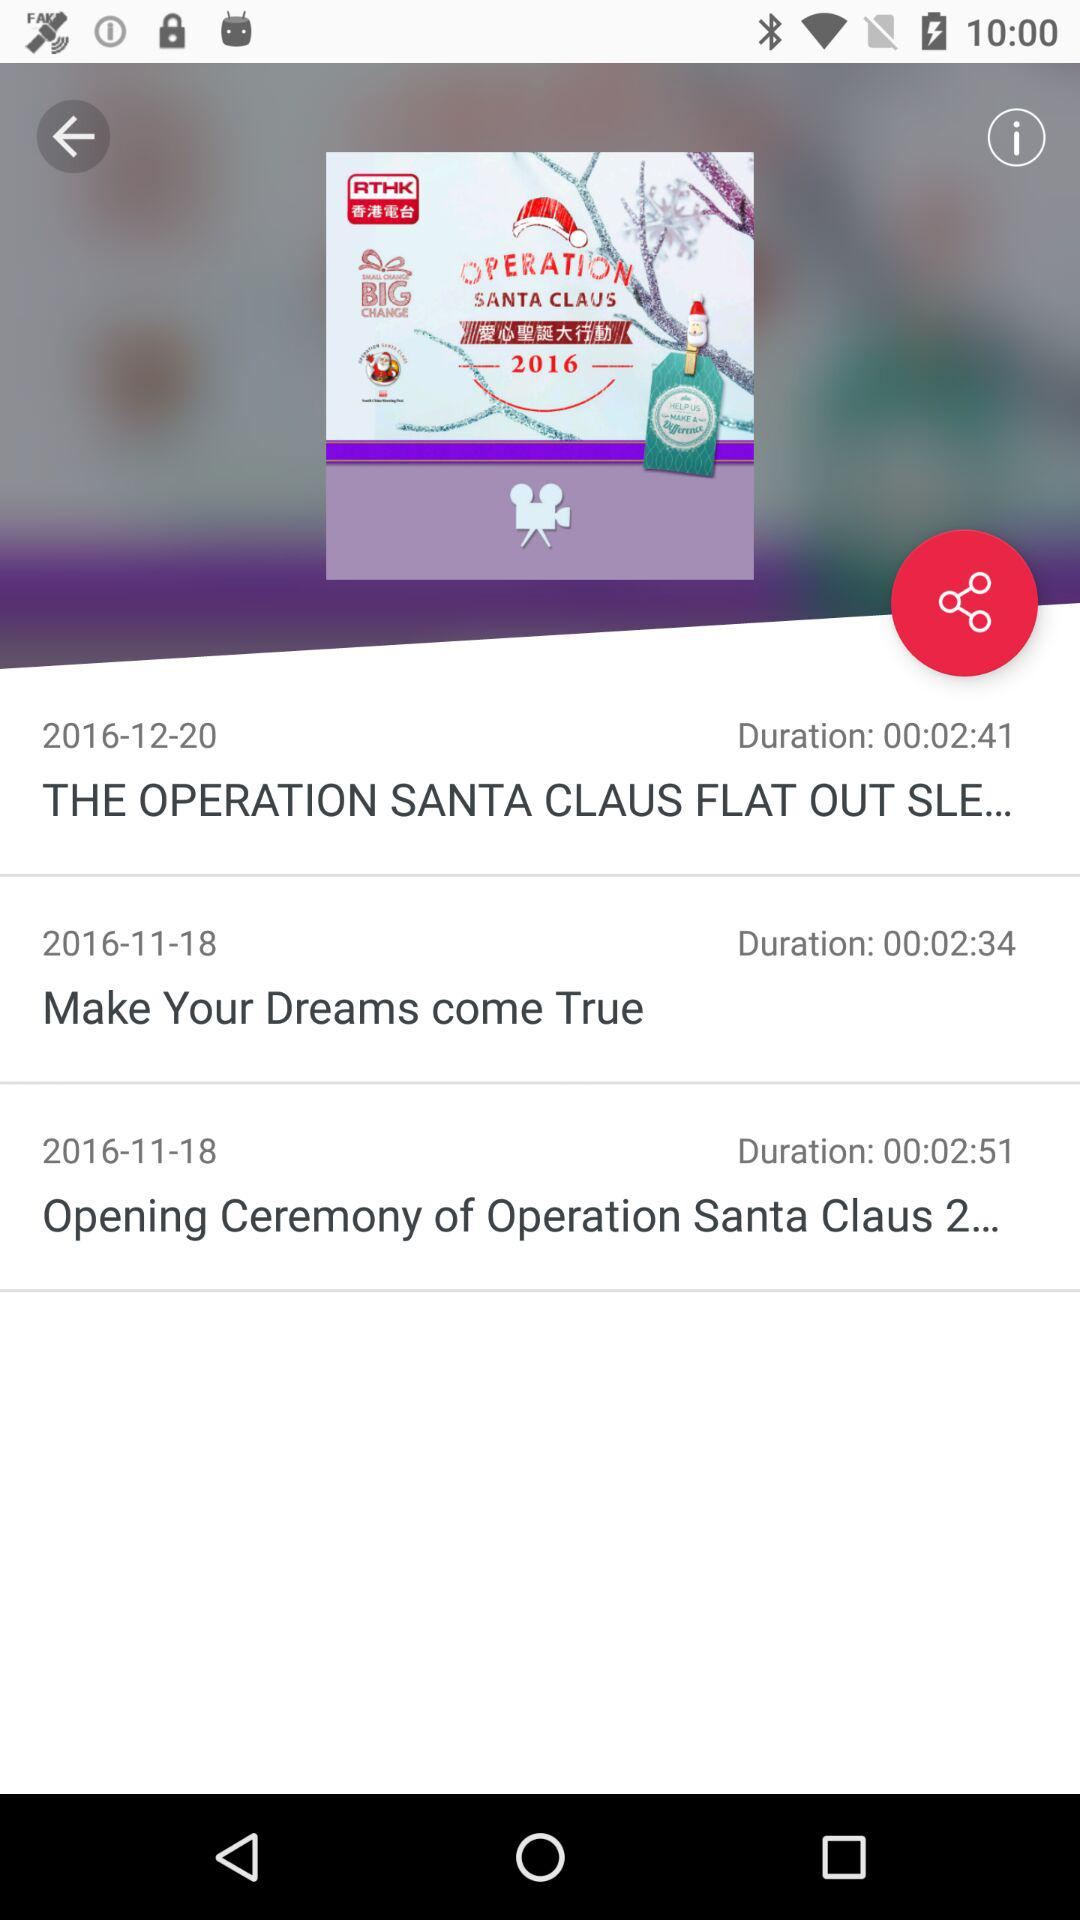How many comments are there?
When the provided information is insufficient, respond with <no answer>. <no answer> 